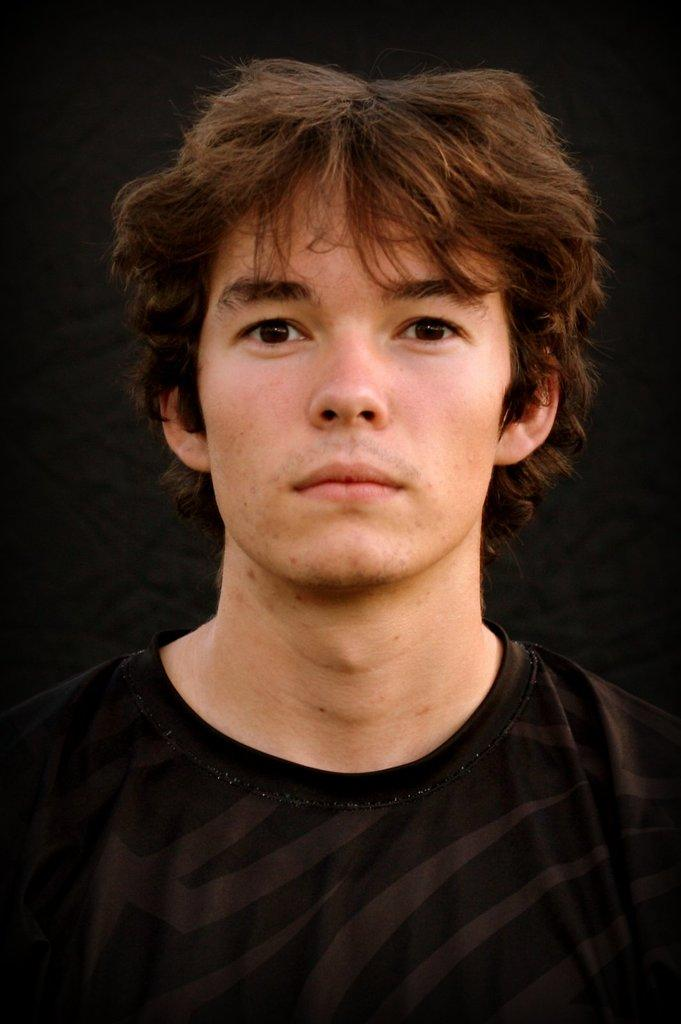Who is the main subject in the image? There is a man in the image. Where is the man located in the image? The man is in the middle of the image. What is the man wearing in the image? The man is wearing a black color T-shirt. What type of yak can be seen in the image? There is no yak present in the image; it features a man wearing a black T-shirt. Where is the library located in the image? There is no library present in the image; it only shows a man in the middle of the image wearing a black T-shirt. 